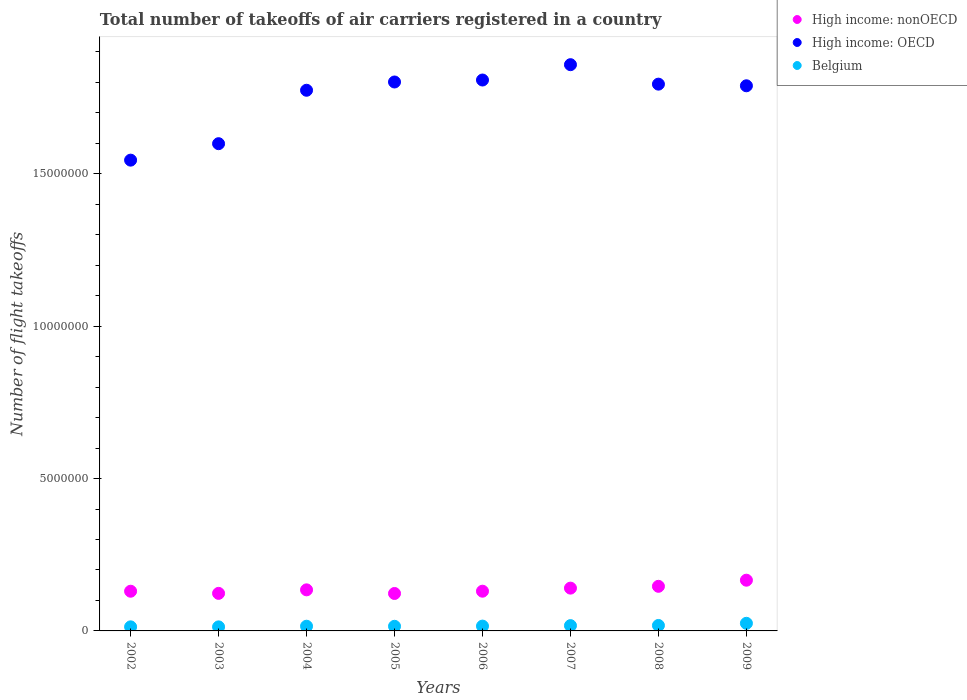How many different coloured dotlines are there?
Provide a succinct answer. 3. What is the total number of flight takeoffs in Belgium in 2003?
Offer a very short reply. 1.33e+05. Across all years, what is the maximum total number of flight takeoffs in High income: OECD?
Your response must be concise. 1.86e+07. Across all years, what is the minimum total number of flight takeoffs in High income: OECD?
Keep it short and to the point. 1.54e+07. In which year was the total number of flight takeoffs in High income: nonOECD minimum?
Give a very brief answer. 2005. What is the total total number of flight takeoffs in High income: OECD in the graph?
Your answer should be compact. 1.40e+08. What is the difference between the total number of flight takeoffs in High income: OECD in 2005 and that in 2008?
Provide a short and direct response. 7.06e+04. What is the difference between the total number of flight takeoffs in High income: OECD in 2003 and the total number of flight takeoffs in Belgium in 2009?
Ensure brevity in your answer.  1.57e+07. What is the average total number of flight takeoffs in Belgium per year?
Give a very brief answer. 1.67e+05. In the year 2009, what is the difference between the total number of flight takeoffs in High income: OECD and total number of flight takeoffs in Belgium?
Offer a very short reply. 1.76e+07. What is the ratio of the total number of flight takeoffs in Belgium in 2002 to that in 2009?
Your response must be concise. 0.53. What is the difference between the highest and the second highest total number of flight takeoffs in High income: OECD?
Offer a terse response. 5.03e+05. What is the difference between the highest and the lowest total number of flight takeoffs in Belgium?
Ensure brevity in your answer.  1.17e+05. In how many years, is the total number of flight takeoffs in Belgium greater than the average total number of flight takeoffs in Belgium taken over all years?
Ensure brevity in your answer.  3. Is the sum of the total number of flight takeoffs in High income: OECD in 2005 and 2007 greater than the maximum total number of flight takeoffs in High income: nonOECD across all years?
Give a very brief answer. Yes. Does the total number of flight takeoffs in High income: nonOECD monotonically increase over the years?
Provide a short and direct response. No. Is the total number of flight takeoffs in High income: nonOECD strictly greater than the total number of flight takeoffs in Belgium over the years?
Your answer should be compact. Yes. Does the graph contain any zero values?
Provide a succinct answer. No. Where does the legend appear in the graph?
Keep it short and to the point. Top right. How many legend labels are there?
Provide a short and direct response. 3. How are the legend labels stacked?
Make the answer very short. Vertical. What is the title of the graph?
Give a very brief answer. Total number of takeoffs of air carriers registered in a country. What is the label or title of the X-axis?
Your response must be concise. Years. What is the label or title of the Y-axis?
Keep it short and to the point. Number of flight takeoffs. What is the Number of flight takeoffs of High income: nonOECD in 2002?
Make the answer very short. 1.30e+06. What is the Number of flight takeoffs of High income: OECD in 2002?
Provide a succinct answer. 1.54e+07. What is the Number of flight takeoffs in Belgium in 2002?
Ensure brevity in your answer.  1.34e+05. What is the Number of flight takeoffs of High income: nonOECD in 2003?
Keep it short and to the point. 1.23e+06. What is the Number of flight takeoffs of High income: OECD in 2003?
Your response must be concise. 1.60e+07. What is the Number of flight takeoffs of Belgium in 2003?
Your answer should be very brief. 1.33e+05. What is the Number of flight takeoffs of High income: nonOECD in 2004?
Provide a succinct answer. 1.35e+06. What is the Number of flight takeoffs of High income: OECD in 2004?
Your answer should be very brief. 1.77e+07. What is the Number of flight takeoffs in Belgium in 2004?
Provide a short and direct response. 1.54e+05. What is the Number of flight takeoffs in High income: nonOECD in 2005?
Provide a short and direct response. 1.23e+06. What is the Number of flight takeoffs in High income: OECD in 2005?
Your answer should be compact. 1.80e+07. What is the Number of flight takeoffs in Belgium in 2005?
Your response must be concise. 1.52e+05. What is the Number of flight takeoffs in High income: nonOECD in 2006?
Offer a terse response. 1.30e+06. What is the Number of flight takeoffs in High income: OECD in 2006?
Give a very brief answer. 1.81e+07. What is the Number of flight takeoffs of Belgium in 2006?
Your answer should be compact. 1.58e+05. What is the Number of flight takeoffs of High income: nonOECD in 2007?
Keep it short and to the point. 1.40e+06. What is the Number of flight takeoffs of High income: OECD in 2007?
Ensure brevity in your answer.  1.86e+07. What is the Number of flight takeoffs in Belgium in 2007?
Keep it short and to the point. 1.74e+05. What is the Number of flight takeoffs in High income: nonOECD in 2008?
Offer a very short reply. 1.46e+06. What is the Number of flight takeoffs in High income: OECD in 2008?
Make the answer very short. 1.79e+07. What is the Number of flight takeoffs in Belgium in 2008?
Offer a very short reply. 1.79e+05. What is the Number of flight takeoffs in High income: nonOECD in 2009?
Offer a terse response. 1.66e+06. What is the Number of flight takeoffs of High income: OECD in 2009?
Your answer should be compact. 1.79e+07. What is the Number of flight takeoffs in Belgium in 2009?
Give a very brief answer. 2.50e+05. Across all years, what is the maximum Number of flight takeoffs of High income: nonOECD?
Offer a terse response. 1.66e+06. Across all years, what is the maximum Number of flight takeoffs in High income: OECD?
Your answer should be compact. 1.86e+07. Across all years, what is the maximum Number of flight takeoffs of Belgium?
Your response must be concise. 2.50e+05. Across all years, what is the minimum Number of flight takeoffs of High income: nonOECD?
Your answer should be compact. 1.23e+06. Across all years, what is the minimum Number of flight takeoffs in High income: OECD?
Offer a very short reply. 1.54e+07. Across all years, what is the minimum Number of flight takeoffs of Belgium?
Ensure brevity in your answer.  1.33e+05. What is the total Number of flight takeoffs of High income: nonOECD in the graph?
Give a very brief answer. 1.09e+07. What is the total Number of flight takeoffs in High income: OECD in the graph?
Give a very brief answer. 1.40e+08. What is the total Number of flight takeoffs of Belgium in the graph?
Your answer should be very brief. 1.33e+06. What is the difference between the Number of flight takeoffs of High income: nonOECD in 2002 and that in 2003?
Your answer should be very brief. 7.03e+04. What is the difference between the Number of flight takeoffs in High income: OECD in 2002 and that in 2003?
Offer a terse response. -5.40e+05. What is the difference between the Number of flight takeoffs of Belgium in 2002 and that in 2003?
Offer a terse response. 903. What is the difference between the Number of flight takeoffs in High income: nonOECD in 2002 and that in 2004?
Your answer should be compact. -4.52e+04. What is the difference between the Number of flight takeoffs in High income: OECD in 2002 and that in 2004?
Give a very brief answer. -2.29e+06. What is the difference between the Number of flight takeoffs in Belgium in 2002 and that in 2004?
Offer a very short reply. -2.05e+04. What is the difference between the Number of flight takeoffs in High income: nonOECD in 2002 and that in 2005?
Your answer should be very brief. 7.38e+04. What is the difference between the Number of flight takeoffs in High income: OECD in 2002 and that in 2005?
Your answer should be very brief. -2.56e+06. What is the difference between the Number of flight takeoffs in Belgium in 2002 and that in 2005?
Make the answer very short. -1.83e+04. What is the difference between the Number of flight takeoffs of High income: nonOECD in 2002 and that in 2006?
Your answer should be compact. -928. What is the difference between the Number of flight takeoffs of High income: OECD in 2002 and that in 2006?
Your answer should be compact. -2.63e+06. What is the difference between the Number of flight takeoffs in Belgium in 2002 and that in 2006?
Your answer should be compact. -2.43e+04. What is the difference between the Number of flight takeoffs in High income: nonOECD in 2002 and that in 2007?
Offer a terse response. -1.02e+05. What is the difference between the Number of flight takeoffs in High income: OECD in 2002 and that in 2007?
Offer a very short reply. -3.13e+06. What is the difference between the Number of flight takeoffs in Belgium in 2002 and that in 2007?
Make the answer very short. -4.01e+04. What is the difference between the Number of flight takeoffs of High income: nonOECD in 2002 and that in 2008?
Make the answer very short. -1.61e+05. What is the difference between the Number of flight takeoffs of High income: OECD in 2002 and that in 2008?
Offer a very short reply. -2.49e+06. What is the difference between the Number of flight takeoffs in Belgium in 2002 and that in 2008?
Provide a short and direct response. -4.53e+04. What is the difference between the Number of flight takeoffs of High income: nonOECD in 2002 and that in 2009?
Make the answer very short. -3.62e+05. What is the difference between the Number of flight takeoffs in High income: OECD in 2002 and that in 2009?
Your answer should be compact. -2.44e+06. What is the difference between the Number of flight takeoffs of Belgium in 2002 and that in 2009?
Ensure brevity in your answer.  -1.16e+05. What is the difference between the Number of flight takeoffs of High income: nonOECD in 2003 and that in 2004?
Provide a succinct answer. -1.15e+05. What is the difference between the Number of flight takeoffs in High income: OECD in 2003 and that in 2004?
Your answer should be very brief. -1.75e+06. What is the difference between the Number of flight takeoffs of Belgium in 2003 and that in 2004?
Offer a very short reply. -2.14e+04. What is the difference between the Number of flight takeoffs in High income: nonOECD in 2003 and that in 2005?
Provide a succinct answer. 3567. What is the difference between the Number of flight takeoffs of High income: OECD in 2003 and that in 2005?
Your response must be concise. -2.02e+06. What is the difference between the Number of flight takeoffs in Belgium in 2003 and that in 2005?
Provide a short and direct response. -1.92e+04. What is the difference between the Number of flight takeoffs of High income: nonOECD in 2003 and that in 2006?
Give a very brief answer. -7.12e+04. What is the difference between the Number of flight takeoffs of High income: OECD in 2003 and that in 2006?
Give a very brief answer. -2.09e+06. What is the difference between the Number of flight takeoffs of Belgium in 2003 and that in 2006?
Offer a terse response. -2.52e+04. What is the difference between the Number of flight takeoffs in High income: nonOECD in 2003 and that in 2007?
Provide a short and direct response. -1.72e+05. What is the difference between the Number of flight takeoffs in High income: OECD in 2003 and that in 2007?
Your response must be concise. -2.59e+06. What is the difference between the Number of flight takeoffs in Belgium in 2003 and that in 2007?
Offer a terse response. -4.10e+04. What is the difference between the Number of flight takeoffs of High income: nonOECD in 2003 and that in 2008?
Offer a very short reply. -2.31e+05. What is the difference between the Number of flight takeoffs in High income: OECD in 2003 and that in 2008?
Your response must be concise. -1.95e+06. What is the difference between the Number of flight takeoffs of Belgium in 2003 and that in 2008?
Ensure brevity in your answer.  -4.62e+04. What is the difference between the Number of flight takeoffs of High income: nonOECD in 2003 and that in 2009?
Make the answer very short. -4.32e+05. What is the difference between the Number of flight takeoffs of High income: OECD in 2003 and that in 2009?
Offer a very short reply. -1.90e+06. What is the difference between the Number of flight takeoffs of Belgium in 2003 and that in 2009?
Your answer should be very brief. -1.17e+05. What is the difference between the Number of flight takeoffs in High income: nonOECD in 2004 and that in 2005?
Your answer should be compact. 1.19e+05. What is the difference between the Number of flight takeoffs of High income: OECD in 2004 and that in 2005?
Your answer should be very brief. -2.71e+05. What is the difference between the Number of flight takeoffs in Belgium in 2004 and that in 2005?
Give a very brief answer. 2279. What is the difference between the Number of flight takeoffs in High income: nonOECD in 2004 and that in 2006?
Offer a very short reply. 4.43e+04. What is the difference between the Number of flight takeoffs of High income: OECD in 2004 and that in 2006?
Offer a terse response. -3.36e+05. What is the difference between the Number of flight takeoffs of Belgium in 2004 and that in 2006?
Your answer should be very brief. -3798. What is the difference between the Number of flight takeoffs in High income: nonOECD in 2004 and that in 2007?
Your answer should be compact. -5.64e+04. What is the difference between the Number of flight takeoffs of High income: OECD in 2004 and that in 2007?
Ensure brevity in your answer.  -8.39e+05. What is the difference between the Number of flight takeoffs in Belgium in 2004 and that in 2007?
Provide a short and direct response. -1.96e+04. What is the difference between the Number of flight takeoffs of High income: nonOECD in 2004 and that in 2008?
Your answer should be very brief. -1.16e+05. What is the difference between the Number of flight takeoffs in High income: OECD in 2004 and that in 2008?
Keep it short and to the point. -2.01e+05. What is the difference between the Number of flight takeoffs of Belgium in 2004 and that in 2008?
Provide a short and direct response. -2.48e+04. What is the difference between the Number of flight takeoffs of High income: nonOECD in 2004 and that in 2009?
Provide a short and direct response. -3.17e+05. What is the difference between the Number of flight takeoffs in High income: OECD in 2004 and that in 2009?
Offer a very short reply. -1.47e+05. What is the difference between the Number of flight takeoffs of Belgium in 2004 and that in 2009?
Keep it short and to the point. -9.58e+04. What is the difference between the Number of flight takeoffs of High income: nonOECD in 2005 and that in 2006?
Ensure brevity in your answer.  -7.48e+04. What is the difference between the Number of flight takeoffs of High income: OECD in 2005 and that in 2006?
Your response must be concise. -6.48e+04. What is the difference between the Number of flight takeoffs in Belgium in 2005 and that in 2006?
Make the answer very short. -6077. What is the difference between the Number of flight takeoffs of High income: nonOECD in 2005 and that in 2007?
Offer a terse response. -1.75e+05. What is the difference between the Number of flight takeoffs of High income: OECD in 2005 and that in 2007?
Provide a short and direct response. -5.68e+05. What is the difference between the Number of flight takeoffs in Belgium in 2005 and that in 2007?
Ensure brevity in your answer.  -2.19e+04. What is the difference between the Number of flight takeoffs in High income: nonOECD in 2005 and that in 2008?
Provide a succinct answer. -2.35e+05. What is the difference between the Number of flight takeoffs of High income: OECD in 2005 and that in 2008?
Provide a succinct answer. 7.06e+04. What is the difference between the Number of flight takeoffs of Belgium in 2005 and that in 2008?
Make the answer very short. -2.71e+04. What is the difference between the Number of flight takeoffs in High income: nonOECD in 2005 and that in 2009?
Your answer should be compact. -4.36e+05. What is the difference between the Number of flight takeoffs of High income: OECD in 2005 and that in 2009?
Provide a short and direct response. 1.24e+05. What is the difference between the Number of flight takeoffs in Belgium in 2005 and that in 2009?
Your answer should be very brief. -9.81e+04. What is the difference between the Number of flight takeoffs of High income: nonOECD in 2006 and that in 2007?
Give a very brief answer. -1.01e+05. What is the difference between the Number of flight takeoffs of High income: OECD in 2006 and that in 2007?
Your answer should be very brief. -5.03e+05. What is the difference between the Number of flight takeoffs in Belgium in 2006 and that in 2007?
Provide a succinct answer. -1.58e+04. What is the difference between the Number of flight takeoffs in High income: nonOECD in 2006 and that in 2008?
Provide a succinct answer. -1.60e+05. What is the difference between the Number of flight takeoffs of High income: OECD in 2006 and that in 2008?
Your response must be concise. 1.35e+05. What is the difference between the Number of flight takeoffs in Belgium in 2006 and that in 2008?
Offer a very short reply. -2.10e+04. What is the difference between the Number of flight takeoffs of High income: nonOECD in 2006 and that in 2009?
Offer a terse response. -3.61e+05. What is the difference between the Number of flight takeoffs in High income: OECD in 2006 and that in 2009?
Provide a short and direct response. 1.89e+05. What is the difference between the Number of flight takeoffs in Belgium in 2006 and that in 2009?
Keep it short and to the point. -9.20e+04. What is the difference between the Number of flight takeoffs of High income: nonOECD in 2007 and that in 2008?
Give a very brief answer. -5.95e+04. What is the difference between the Number of flight takeoffs in High income: OECD in 2007 and that in 2008?
Provide a succinct answer. 6.38e+05. What is the difference between the Number of flight takeoffs of Belgium in 2007 and that in 2008?
Your answer should be very brief. -5201. What is the difference between the Number of flight takeoffs in High income: nonOECD in 2007 and that in 2009?
Ensure brevity in your answer.  -2.60e+05. What is the difference between the Number of flight takeoffs in High income: OECD in 2007 and that in 2009?
Offer a terse response. 6.92e+05. What is the difference between the Number of flight takeoffs in Belgium in 2007 and that in 2009?
Provide a short and direct response. -7.62e+04. What is the difference between the Number of flight takeoffs of High income: nonOECD in 2008 and that in 2009?
Your response must be concise. -2.01e+05. What is the difference between the Number of flight takeoffs in High income: OECD in 2008 and that in 2009?
Your answer should be compact. 5.38e+04. What is the difference between the Number of flight takeoffs of Belgium in 2008 and that in 2009?
Give a very brief answer. -7.10e+04. What is the difference between the Number of flight takeoffs of High income: nonOECD in 2002 and the Number of flight takeoffs of High income: OECD in 2003?
Ensure brevity in your answer.  -1.47e+07. What is the difference between the Number of flight takeoffs in High income: nonOECD in 2002 and the Number of flight takeoffs in Belgium in 2003?
Ensure brevity in your answer.  1.17e+06. What is the difference between the Number of flight takeoffs of High income: OECD in 2002 and the Number of flight takeoffs of Belgium in 2003?
Offer a very short reply. 1.53e+07. What is the difference between the Number of flight takeoffs of High income: nonOECD in 2002 and the Number of flight takeoffs of High income: OECD in 2004?
Provide a short and direct response. -1.64e+07. What is the difference between the Number of flight takeoffs in High income: nonOECD in 2002 and the Number of flight takeoffs in Belgium in 2004?
Keep it short and to the point. 1.15e+06. What is the difference between the Number of flight takeoffs in High income: OECD in 2002 and the Number of flight takeoffs in Belgium in 2004?
Give a very brief answer. 1.53e+07. What is the difference between the Number of flight takeoffs in High income: nonOECD in 2002 and the Number of flight takeoffs in High income: OECD in 2005?
Your answer should be very brief. -1.67e+07. What is the difference between the Number of flight takeoffs of High income: nonOECD in 2002 and the Number of flight takeoffs of Belgium in 2005?
Offer a terse response. 1.15e+06. What is the difference between the Number of flight takeoffs of High income: OECD in 2002 and the Number of flight takeoffs of Belgium in 2005?
Your answer should be very brief. 1.53e+07. What is the difference between the Number of flight takeoffs of High income: nonOECD in 2002 and the Number of flight takeoffs of High income: OECD in 2006?
Give a very brief answer. -1.68e+07. What is the difference between the Number of flight takeoffs in High income: nonOECD in 2002 and the Number of flight takeoffs in Belgium in 2006?
Ensure brevity in your answer.  1.14e+06. What is the difference between the Number of flight takeoffs in High income: OECD in 2002 and the Number of flight takeoffs in Belgium in 2006?
Your response must be concise. 1.53e+07. What is the difference between the Number of flight takeoffs of High income: nonOECD in 2002 and the Number of flight takeoffs of High income: OECD in 2007?
Offer a very short reply. -1.73e+07. What is the difference between the Number of flight takeoffs of High income: nonOECD in 2002 and the Number of flight takeoffs of Belgium in 2007?
Provide a short and direct response. 1.13e+06. What is the difference between the Number of flight takeoffs of High income: OECD in 2002 and the Number of flight takeoffs of Belgium in 2007?
Your answer should be compact. 1.53e+07. What is the difference between the Number of flight takeoffs in High income: nonOECD in 2002 and the Number of flight takeoffs in High income: OECD in 2008?
Make the answer very short. -1.66e+07. What is the difference between the Number of flight takeoffs in High income: nonOECD in 2002 and the Number of flight takeoffs in Belgium in 2008?
Keep it short and to the point. 1.12e+06. What is the difference between the Number of flight takeoffs of High income: OECD in 2002 and the Number of flight takeoffs of Belgium in 2008?
Provide a short and direct response. 1.53e+07. What is the difference between the Number of flight takeoffs in High income: nonOECD in 2002 and the Number of flight takeoffs in High income: OECD in 2009?
Offer a very short reply. -1.66e+07. What is the difference between the Number of flight takeoffs of High income: nonOECD in 2002 and the Number of flight takeoffs of Belgium in 2009?
Your answer should be very brief. 1.05e+06. What is the difference between the Number of flight takeoffs in High income: OECD in 2002 and the Number of flight takeoffs in Belgium in 2009?
Offer a very short reply. 1.52e+07. What is the difference between the Number of flight takeoffs in High income: nonOECD in 2003 and the Number of flight takeoffs in High income: OECD in 2004?
Offer a very short reply. -1.65e+07. What is the difference between the Number of flight takeoffs of High income: nonOECD in 2003 and the Number of flight takeoffs of Belgium in 2004?
Provide a short and direct response. 1.08e+06. What is the difference between the Number of flight takeoffs in High income: OECD in 2003 and the Number of flight takeoffs in Belgium in 2004?
Offer a very short reply. 1.58e+07. What is the difference between the Number of flight takeoffs of High income: nonOECD in 2003 and the Number of flight takeoffs of High income: OECD in 2005?
Ensure brevity in your answer.  -1.68e+07. What is the difference between the Number of flight takeoffs in High income: nonOECD in 2003 and the Number of flight takeoffs in Belgium in 2005?
Offer a very short reply. 1.08e+06. What is the difference between the Number of flight takeoffs of High income: OECD in 2003 and the Number of flight takeoffs of Belgium in 2005?
Keep it short and to the point. 1.58e+07. What is the difference between the Number of flight takeoffs in High income: nonOECD in 2003 and the Number of flight takeoffs in High income: OECD in 2006?
Offer a terse response. -1.68e+07. What is the difference between the Number of flight takeoffs of High income: nonOECD in 2003 and the Number of flight takeoffs of Belgium in 2006?
Ensure brevity in your answer.  1.07e+06. What is the difference between the Number of flight takeoffs of High income: OECD in 2003 and the Number of flight takeoffs of Belgium in 2006?
Ensure brevity in your answer.  1.58e+07. What is the difference between the Number of flight takeoffs in High income: nonOECD in 2003 and the Number of flight takeoffs in High income: OECD in 2007?
Offer a terse response. -1.73e+07. What is the difference between the Number of flight takeoffs in High income: nonOECD in 2003 and the Number of flight takeoffs in Belgium in 2007?
Your answer should be compact. 1.06e+06. What is the difference between the Number of flight takeoffs in High income: OECD in 2003 and the Number of flight takeoffs in Belgium in 2007?
Keep it short and to the point. 1.58e+07. What is the difference between the Number of flight takeoffs of High income: nonOECD in 2003 and the Number of flight takeoffs of High income: OECD in 2008?
Your answer should be compact. -1.67e+07. What is the difference between the Number of flight takeoffs of High income: nonOECD in 2003 and the Number of flight takeoffs of Belgium in 2008?
Ensure brevity in your answer.  1.05e+06. What is the difference between the Number of flight takeoffs in High income: OECD in 2003 and the Number of flight takeoffs in Belgium in 2008?
Your response must be concise. 1.58e+07. What is the difference between the Number of flight takeoffs of High income: nonOECD in 2003 and the Number of flight takeoffs of High income: OECD in 2009?
Your response must be concise. -1.67e+07. What is the difference between the Number of flight takeoffs in High income: nonOECD in 2003 and the Number of flight takeoffs in Belgium in 2009?
Offer a very short reply. 9.82e+05. What is the difference between the Number of flight takeoffs in High income: OECD in 2003 and the Number of flight takeoffs in Belgium in 2009?
Your response must be concise. 1.57e+07. What is the difference between the Number of flight takeoffs in High income: nonOECD in 2004 and the Number of flight takeoffs in High income: OECD in 2005?
Provide a short and direct response. -1.67e+07. What is the difference between the Number of flight takeoffs of High income: nonOECD in 2004 and the Number of flight takeoffs of Belgium in 2005?
Offer a very short reply. 1.20e+06. What is the difference between the Number of flight takeoffs in High income: OECD in 2004 and the Number of flight takeoffs in Belgium in 2005?
Ensure brevity in your answer.  1.76e+07. What is the difference between the Number of flight takeoffs in High income: nonOECD in 2004 and the Number of flight takeoffs in High income: OECD in 2006?
Offer a terse response. -1.67e+07. What is the difference between the Number of flight takeoffs in High income: nonOECD in 2004 and the Number of flight takeoffs in Belgium in 2006?
Offer a terse response. 1.19e+06. What is the difference between the Number of flight takeoffs of High income: OECD in 2004 and the Number of flight takeoffs of Belgium in 2006?
Provide a short and direct response. 1.76e+07. What is the difference between the Number of flight takeoffs in High income: nonOECD in 2004 and the Number of flight takeoffs in High income: OECD in 2007?
Make the answer very short. -1.72e+07. What is the difference between the Number of flight takeoffs in High income: nonOECD in 2004 and the Number of flight takeoffs in Belgium in 2007?
Keep it short and to the point. 1.17e+06. What is the difference between the Number of flight takeoffs in High income: OECD in 2004 and the Number of flight takeoffs in Belgium in 2007?
Your response must be concise. 1.76e+07. What is the difference between the Number of flight takeoffs of High income: nonOECD in 2004 and the Number of flight takeoffs of High income: OECD in 2008?
Give a very brief answer. -1.66e+07. What is the difference between the Number of flight takeoffs of High income: nonOECD in 2004 and the Number of flight takeoffs of Belgium in 2008?
Offer a terse response. 1.17e+06. What is the difference between the Number of flight takeoffs of High income: OECD in 2004 and the Number of flight takeoffs of Belgium in 2008?
Offer a very short reply. 1.76e+07. What is the difference between the Number of flight takeoffs in High income: nonOECD in 2004 and the Number of flight takeoffs in High income: OECD in 2009?
Make the answer very short. -1.65e+07. What is the difference between the Number of flight takeoffs of High income: nonOECD in 2004 and the Number of flight takeoffs of Belgium in 2009?
Provide a short and direct response. 1.10e+06. What is the difference between the Number of flight takeoffs of High income: OECD in 2004 and the Number of flight takeoffs of Belgium in 2009?
Make the answer very short. 1.75e+07. What is the difference between the Number of flight takeoffs of High income: nonOECD in 2005 and the Number of flight takeoffs of High income: OECD in 2006?
Keep it short and to the point. -1.68e+07. What is the difference between the Number of flight takeoffs in High income: nonOECD in 2005 and the Number of flight takeoffs in Belgium in 2006?
Give a very brief answer. 1.07e+06. What is the difference between the Number of flight takeoffs in High income: OECD in 2005 and the Number of flight takeoffs in Belgium in 2006?
Offer a terse response. 1.79e+07. What is the difference between the Number of flight takeoffs in High income: nonOECD in 2005 and the Number of flight takeoffs in High income: OECD in 2007?
Give a very brief answer. -1.74e+07. What is the difference between the Number of flight takeoffs in High income: nonOECD in 2005 and the Number of flight takeoffs in Belgium in 2007?
Keep it short and to the point. 1.05e+06. What is the difference between the Number of flight takeoffs in High income: OECD in 2005 and the Number of flight takeoffs in Belgium in 2007?
Your response must be concise. 1.78e+07. What is the difference between the Number of flight takeoffs of High income: nonOECD in 2005 and the Number of flight takeoffs of High income: OECD in 2008?
Offer a very short reply. -1.67e+07. What is the difference between the Number of flight takeoffs in High income: nonOECD in 2005 and the Number of flight takeoffs in Belgium in 2008?
Provide a short and direct response. 1.05e+06. What is the difference between the Number of flight takeoffs in High income: OECD in 2005 and the Number of flight takeoffs in Belgium in 2008?
Offer a terse response. 1.78e+07. What is the difference between the Number of flight takeoffs of High income: nonOECD in 2005 and the Number of flight takeoffs of High income: OECD in 2009?
Ensure brevity in your answer.  -1.67e+07. What is the difference between the Number of flight takeoffs of High income: nonOECD in 2005 and the Number of flight takeoffs of Belgium in 2009?
Give a very brief answer. 9.79e+05. What is the difference between the Number of flight takeoffs in High income: OECD in 2005 and the Number of flight takeoffs in Belgium in 2009?
Keep it short and to the point. 1.78e+07. What is the difference between the Number of flight takeoffs in High income: nonOECD in 2006 and the Number of flight takeoffs in High income: OECD in 2007?
Keep it short and to the point. -1.73e+07. What is the difference between the Number of flight takeoffs in High income: nonOECD in 2006 and the Number of flight takeoffs in Belgium in 2007?
Your answer should be very brief. 1.13e+06. What is the difference between the Number of flight takeoffs of High income: OECD in 2006 and the Number of flight takeoffs of Belgium in 2007?
Offer a very short reply. 1.79e+07. What is the difference between the Number of flight takeoffs in High income: nonOECD in 2006 and the Number of flight takeoffs in High income: OECD in 2008?
Your response must be concise. -1.66e+07. What is the difference between the Number of flight takeoffs in High income: nonOECD in 2006 and the Number of flight takeoffs in Belgium in 2008?
Give a very brief answer. 1.12e+06. What is the difference between the Number of flight takeoffs in High income: OECD in 2006 and the Number of flight takeoffs in Belgium in 2008?
Provide a short and direct response. 1.79e+07. What is the difference between the Number of flight takeoffs of High income: nonOECD in 2006 and the Number of flight takeoffs of High income: OECD in 2009?
Provide a succinct answer. -1.66e+07. What is the difference between the Number of flight takeoffs in High income: nonOECD in 2006 and the Number of flight takeoffs in Belgium in 2009?
Offer a terse response. 1.05e+06. What is the difference between the Number of flight takeoffs in High income: OECD in 2006 and the Number of flight takeoffs in Belgium in 2009?
Make the answer very short. 1.78e+07. What is the difference between the Number of flight takeoffs in High income: nonOECD in 2007 and the Number of flight takeoffs in High income: OECD in 2008?
Your answer should be very brief. -1.65e+07. What is the difference between the Number of flight takeoffs of High income: nonOECD in 2007 and the Number of flight takeoffs of Belgium in 2008?
Make the answer very short. 1.23e+06. What is the difference between the Number of flight takeoffs of High income: OECD in 2007 and the Number of flight takeoffs of Belgium in 2008?
Provide a succinct answer. 1.84e+07. What is the difference between the Number of flight takeoffs of High income: nonOECD in 2007 and the Number of flight takeoffs of High income: OECD in 2009?
Your answer should be very brief. -1.65e+07. What is the difference between the Number of flight takeoffs of High income: nonOECD in 2007 and the Number of flight takeoffs of Belgium in 2009?
Provide a succinct answer. 1.15e+06. What is the difference between the Number of flight takeoffs of High income: OECD in 2007 and the Number of flight takeoffs of Belgium in 2009?
Your response must be concise. 1.83e+07. What is the difference between the Number of flight takeoffs of High income: nonOECD in 2008 and the Number of flight takeoffs of High income: OECD in 2009?
Your response must be concise. -1.64e+07. What is the difference between the Number of flight takeoffs of High income: nonOECD in 2008 and the Number of flight takeoffs of Belgium in 2009?
Provide a short and direct response. 1.21e+06. What is the difference between the Number of flight takeoffs in High income: OECD in 2008 and the Number of flight takeoffs in Belgium in 2009?
Provide a short and direct response. 1.77e+07. What is the average Number of flight takeoffs in High income: nonOECD per year?
Provide a short and direct response. 1.37e+06. What is the average Number of flight takeoffs of High income: OECD per year?
Your response must be concise. 1.75e+07. What is the average Number of flight takeoffs of Belgium per year?
Your response must be concise. 1.67e+05. In the year 2002, what is the difference between the Number of flight takeoffs of High income: nonOECD and Number of flight takeoffs of High income: OECD?
Ensure brevity in your answer.  -1.41e+07. In the year 2002, what is the difference between the Number of flight takeoffs in High income: nonOECD and Number of flight takeoffs in Belgium?
Provide a succinct answer. 1.17e+06. In the year 2002, what is the difference between the Number of flight takeoffs of High income: OECD and Number of flight takeoffs of Belgium?
Provide a short and direct response. 1.53e+07. In the year 2003, what is the difference between the Number of flight takeoffs in High income: nonOECD and Number of flight takeoffs in High income: OECD?
Keep it short and to the point. -1.48e+07. In the year 2003, what is the difference between the Number of flight takeoffs of High income: nonOECD and Number of flight takeoffs of Belgium?
Your answer should be compact. 1.10e+06. In the year 2003, what is the difference between the Number of flight takeoffs in High income: OECD and Number of flight takeoffs in Belgium?
Your answer should be very brief. 1.59e+07. In the year 2004, what is the difference between the Number of flight takeoffs in High income: nonOECD and Number of flight takeoffs in High income: OECD?
Your answer should be compact. -1.64e+07. In the year 2004, what is the difference between the Number of flight takeoffs of High income: nonOECD and Number of flight takeoffs of Belgium?
Give a very brief answer. 1.19e+06. In the year 2004, what is the difference between the Number of flight takeoffs in High income: OECD and Number of flight takeoffs in Belgium?
Offer a terse response. 1.76e+07. In the year 2005, what is the difference between the Number of flight takeoffs in High income: nonOECD and Number of flight takeoffs in High income: OECD?
Keep it short and to the point. -1.68e+07. In the year 2005, what is the difference between the Number of flight takeoffs of High income: nonOECD and Number of flight takeoffs of Belgium?
Offer a very short reply. 1.08e+06. In the year 2005, what is the difference between the Number of flight takeoffs of High income: OECD and Number of flight takeoffs of Belgium?
Offer a terse response. 1.79e+07. In the year 2006, what is the difference between the Number of flight takeoffs of High income: nonOECD and Number of flight takeoffs of High income: OECD?
Give a very brief answer. -1.68e+07. In the year 2006, what is the difference between the Number of flight takeoffs of High income: nonOECD and Number of flight takeoffs of Belgium?
Offer a very short reply. 1.15e+06. In the year 2006, what is the difference between the Number of flight takeoffs in High income: OECD and Number of flight takeoffs in Belgium?
Ensure brevity in your answer.  1.79e+07. In the year 2007, what is the difference between the Number of flight takeoffs of High income: nonOECD and Number of flight takeoffs of High income: OECD?
Your answer should be compact. -1.72e+07. In the year 2007, what is the difference between the Number of flight takeoffs of High income: nonOECD and Number of flight takeoffs of Belgium?
Give a very brief answer. 1.23e+06. In the year 2007, what is the difference between the Number of flight takeoffs of High income: OECD and Number of flight takeoffs of Belgium?
Ensure brevity in your answer.  1.84e+07. In the year 2008, what is the difference between the Number of flight takeoffs in High income: nonOECD and Number of flight takeoffs in High income: OECD?
Make the answer very short. -1.65e+07. In the year 2008, what is the difference between the Number of flight takeoffs in High income: nonOECD and Number of flight takeoffs in Belgium?
Provide a short and direct response. 1.28e+06. In the year 2008, what is the difference between the Number of flight takeoffs of High income: OECD and Number of flight takeoffs of Belgium?
Keep it short and to the point. 1.78e+07. In the year 2009, what is the difference between the Number of flight takeoffs of High income: nonOECD and Number of flight takeoffs of High income: OECD?
Ensure brevity in your answer.  -1.62e+07. In the year 2009, what is the difference between the Number of flight takeoffs in High income: nonOECD and Number of flight takeoffs in Belgium?
Give a very brief answer. 1.41e+06. In the year 2009, what is the difference between the Number of flight takeoffs in High income: OECD and Number of flight takeoffs in Belgium?
Give a very brief answer. 1.76e+07. What is the ratio of the Number of flight takeoffs in High income: nonOECD in 2002 to that in 2003?
Give a very brief answer. 1.06. What is the ratio of the Number of flight takeoffs in High income: OECD in 2002 to that in 2003?
Keep it short and to the point. 0.97. What is the ratio of the Number of flight takeoffs of Belgium in 2002 to that in 2003?
Offer a very short reply. 1.01. What is the ratio of the Number of flight takeoffs in High income: nonOECD in 2002 to that in 2004?
Offer a terse response. 0.97. What is the ratio of the Number of flight takeoffs of High income: OECD in 2002 to that in 2004?
Make the answer very short. 0.87. What is the ratio of the Number of flight takeoffs of Belgium in 2002 to that in 2004?
Ensure brevity in your answer.  0.87. What is the ratio of the Number of flight takeoffs of High income: nonOECD in 2002 to that in 2005?
Offer a very short reply. 1.06. What is the ratio of the Number of flight takeoffs of High income: OECD in 2002 to that in 2005?
Give a very brief answer. 0.86. What is the ratio of the Number of flight takeoffs in Belgium in 2002 to that in 2005?
Make the answer very short. 0.88. What is the ratio of the Number of flight takeoffs in High income: OECD in 2002 to that in 2006?
Keep it short and to the point. 0.85. What is the ratio of the Number of flight takeoffs of Belgium in 2002 to that in 2006?
Your answer should be compact. 0.85. What is the ratio of the Number of flight takeoffs of High income: nonOECD in 2002 to that in 2007?
Make the answer very short. 0.93. What is the ratio of the Number of flight takeoffs in High income: OECD in 2002 to that in 2007?
Offer a very short reply. 0.83. What is the ratio of the Number of flight takeoffs of Belgium in 2002 to that in 2007?
Provide a succinct answer. 0.77. What is the ratio of the Number of flight takeoffs in High income: nonOECD in 2002 to that in 2008?
Provide a succinct answer. 0.89. What is the ratio of the Number of flight takeoffs of High income: OECD in 2002 to that in 2008?
Give a very brief answer. 0.86. What is the ratio of the Number of flight takeoffs in Belgium in 2002 to that in 2008?
Provide a short and direct response. 0.75. What is the ratio of the Number of flight takeoffs of High income: nonOECD in 2002 to that in 2009?
Offer a terse response. 0.78. What is the ratio of the Number of flight takeoffs in High income: OECD in 2002 to that in 2009?
Your answer should be compact. 0.86. What is the ratio of the Number of flight takeoffs in Belgium in 2002 to that in 2009?
Make the answer very short. 0.53. What is the ratio of the Number of flight takeoffs of High income: nonOECD in 2003 to that in 2004?
Offer a very short reply. 0.91. What is the ratio of the Number of flight takeoffs of High income: OECD in 2003 to that in 2004?
Your answer should be very brief. 0.9. What is the ratio of the Number of flight takeoffs in Belgium in 2003 to that in 2004?
Provide a short and direct response. 0.86. What is the ratio of the Number of flight takeoffs of High income: nonOECD in 2003 to that in 2005?
Provide a short and direct response. 1. What is the ratio of the Number of flight takeoffs in High income: OECD in 2003 to that in 2005?
Offer a very short reply. 0.89. What is the ratio of the Number of flight takeoffs of Belgium in 2003 to that in 2005?
Your response must be concise. 0.87. What is the ratio of the Number of flight takeoffs in High income: nonOECD in 2003 to that in 2006?
Your answer should be very brief. 0.95. What is the ratio of the Number of flight takeoffs of High income: OECD in 2003 to that in 2006?
Give a very brief answer. 0.88. What is the ratio of the Number of flight takeoffs in Belgium in 2003 to that in 2006?
Give a very brief answer. 0.84. What is the ratio of the Number of flight takeoffs of High income: nonOECD in 2003 to that in 2007?
Ensure brevity in your answer.  0.88. What is the ratio of the Number of flight takeoffs in High income: OECD in 2003 to that in 2007?
Provide a short and direct response. 0.86. What is the ratio of the Number of flight takeoffs in Belgium in 2003 to that in 2007?
Your answer should be compact. 0.76. What is the ratio of the Number of flight takeoffs in High income: nonOECD in 2003 to that in 2008?
Keep it short and to the point. 0.84. What is the ratio of the Number of flight takeoffs in High income: OECD in 2003 to that in 2008?
Offer a very short reply. 0.89. What is the ratio of the Number of flight takeoffs of Belgium in 2003 to that in 2008?
Ensure brevity in your answer.  0.74. What is the ratio of the Number of flight takeoffs of High income: nonOECD in 2003 to that in 2009?
Give a very brief answer. 0.74. What is the ratio of the Number of flight takeoffs in High income: OECD in 2003 to that in 2009?
Give a very brief answer. 0.89. What is the ratio of the Number of flight takeoffs in Belgium in 2003 to that in 2009?
Make the answer very short. 0.53. What is the ratio of the Number of flight takeoffs in High income: nonOECD in 2004 to that in 2005?
Ensure brevity in your answer.  1.1. What is the ratio of the Number of flight takeoffs in High income: OECD in 2004 to that in 2005?
Your response must be concise. 0.98. What is the ratio of the Number of flight takeoffs of High income: nonOECD in 2004 to that in 2006?
Offer a very short reply. 1.03. What is the ratio of the Number of flight takeoffs in High income: OECD in 2004 to that in 2006?
Offer a terse response. 0.98. What is the ratio of the Number of flight takeoffs in Belgium in 2004 to that in 2006?
Make the answer very short. 0.98. What is the ratio of the Number of flight takeoffs of High income: nonOECD in 2004 to that in 2007?
Give a very brief answer. 0.96. What is the ratio of the Number of flight takeoffs of High income: OECD in 2004 to that in 2007?
Offer a very short reply. 0.95. What is the ratio of the Number of flight takeoffs in Belgium in 2004 to that in 2007?
Your answer should be compact. 0.89. What is the ratio of the Number of flight takeoffs of High income: nonOECD in 2004 to that in 2008?
Your response must be concise. 0.92. What is the ratio of the Number of flight takeoffs of Belgium in 2004 to that in 2008?
Give a very brief answer. 0.86. What is the ratio of the Number of flight takeoffs in High income: nonOECD in 2004 to that in 2009?
Provide a short and direct response. 0.81. What is the ratio of the Number of flight takeoffs of High income: OECD in 2004 to that in 2009?
Offer a terse response. 0.99. What is the ratio of the Number of flight takeoffs of Belgium in 2004 to that in 2009?
Your answer should be compact. 0.62. What is the ratio of the Number of flight takeoffs of High income: nonOECD in 2005 to that in 2006?
Offer a very short reply. 0.94. What is the ratio of the Number of flight takeoffs of High income: OECD in 2005 to that in 2006?
Keep it short and to the point. 1. What is the ratio of the Number of flight takeoffs in Belgium in 2005 to that in 2006?
Your answer should be very brief. 0.96. What is the ratio of the Number of flight takeoffs of High income: nonOECD in 2005 to that in 2007?
Provide a short and direct response. 0.88. What is the ratio of the Number of flight takeoffs in High income: OECD in 2005 to that in 2007?
Provide a short and direct response. 0.97. What is the ratio of the Number of flight takeoffs of Belgium in 2005 to that in 2007?
Your answer should be compact. 0.87. What is the ratio of the Number of flight takeoffs in High income: nonOECD in 2005 to that in 2008?
Your answer should be very brief. 0.84. What is the ratio of the Number of flight takeoffs in High income: OECD in 2005 to that in 2008?
Your answer should be very brief. 1. What is the ratio of the Number of flight takeoffs in Belgium in 2005 to that in 2008?
Provide a succinct answer. 0.85. What is the ratio of the Number of flight takeoffs of High income: nonOECD in 2005 to that in 2009?
Offer a very short reply. 0.74. What is the ratio of the Number of flight takeoffs of High income: OECD in 2005 to that in 2009?
Provide a succinct answer. 1.01. What is the ratio of the Number of flight takeoffs of Belgium in 2005 to that in 2009?
Make the answer very short. 0.61. What is the ratio of the Number of flight takeoffs of High income: nonOECD in 2006 to that in 2007?
Offer a very short reply. 0.93. What is the ratio of the Number of flight takeoffs in High income: OECD in 2006 to that in 2007?
Ensure brevity in your answer.  0.97. What is the ratio of the Number of flight takeoffs of High income: nonOECD in 2006 to that in 2008?
Make the answer very short. 0.89. What is the ratio of the Number of flight takeoffs in High income: OECD in 2006 to that in 2008?
Provide a short and direct response. 1.01. What is the ratio of the Number of flight takeoffs of Belgium in 2006 to that in 2008?
Make the answer very short. 0.88. What is the ratio of the Number of flight takeoffs of High income: nonOECD in 2006 to that in 2009?
Make the answer very short. 0.78. What is the ratio of the Number of flight takeoffs in High income: OECD in 2006 to that in 2009?
Provide a short and direct response. 1.01. What is the ratio of the Number of flight takeoffs in Belgium in 2006 to that in 2009?
Keep it short and to the point. 0.63. What is the ratio of the Number of flight takeoffs in High income: nonOECD in 2007 to that in 2008?
Your answer should be compact. 0.96. What is the ratio of the Number of flight takeoffs of High income: OECD in 2007 to that in 2008?
Provide a short and direct response. 1.04. What is the ratio of the Number of flight takeoffs of Belgium in 2007 to that in 2008?
Offer a very short reply. 0.97. What is the ratio of the Number of flight takeoffs in High income: nonOECD in 2007 to that in 2009?
Give a very brief answer. 0.84. What is the ratio of the Number of flight takeoffs of High income: OECD in 2007 to that in 2009?
Ensure brevity in your answer.  1.04. What is the ratio of the Number of flight takeoffs of Belgium in 2007 to that in 2009?
Ensure brevity in your answer.  0.7. What is the ratio of the Number of flight takeoffs of High income: nonOECD in 2008 to that in 2009?
Keep it short and to the point. 0.88. What is the ratio of the Number of flight takeoffs in Belgium in 2008 to that in 2009?
Offer a very short reply. 0.72. What is the difference between the highest and the second highest Number of flight takeoffs of High income: nonOECD?
Offer a terse response. 2.01e+05. What is the difference between the highest and the second highest Number of flight takeoffs of High income: OECD?
Make the answer very short. 5.03e+05. What is the difference between the highest and the second highest Number of flight takeoffs in Belgium?
Make the answer very short. 7.10e+04. What is the difference between the highest and the lowest Number of flight takeoffs of High income: nonOECD?
Offer a very short reply. 4.36e+05. What is the difference between the highest and the lowest Number of flight takeoffs in High income: OECD?
Offer a very short reply. 3.13e+06. What is the difference between the highest and the lowest Number of flight takeoffs in Belgium?
Your answer should be very brief. 1.17e+05. 